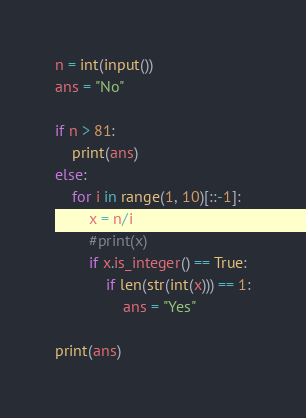<code> <loc_0><loc_0><loc_500><loc_500><_Python_>n = int(input())
ans = "No"

if n > 81:
    print(ans)
else:
    for i in range(1, 10)[::-1]:
        x = n/i
        #print(x)
        if x.is_integer() == True:
            if len(str(int(x))) == 1:
                ans = "Yes"

print(ans)</code> 